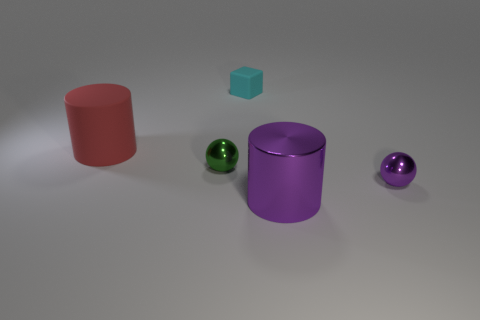Subtract all cylinders. How many objects are left? 3 Subtract 1 blocks. How many blocks are left? 0 Subtract all cyan cylinders. Subtract all yellow blocks. How many cylinders are left? 2 Subtract all yellow spheres. How many green cubes are left? 0 Subtract all tiny cyan rubber cubes. Subtract all cyan spheres. How many objects are left? 4 Add 2 matte things. How many matte things are left? 4 Add 1 small matte things. How many small matte things exist? 2 Add 3 big brown objects. How many objects exist? 8 Subtract all purple cylinders. How many cylinders are left? 1 Subtract 0 green cylinders. How many objects are left? 5 